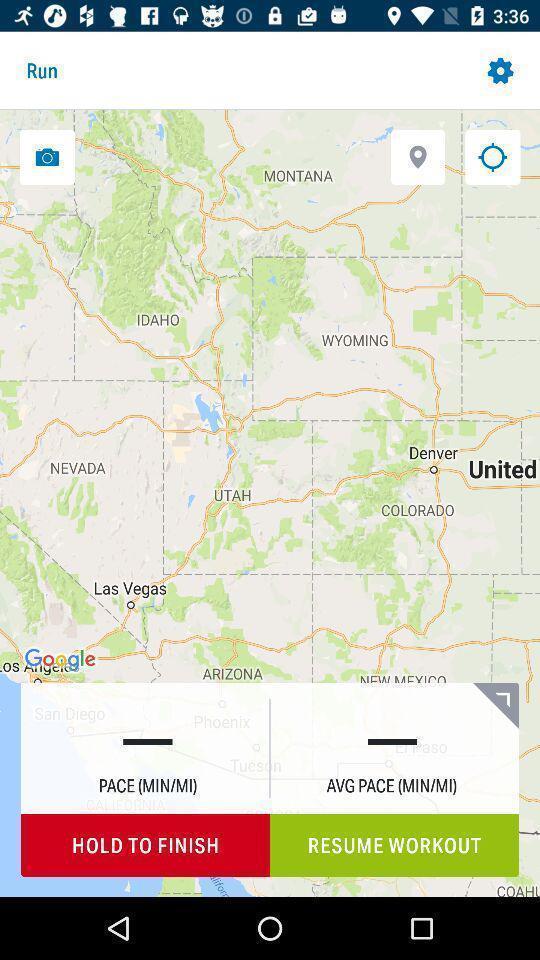Describe the key features of this screenshot. Screen showing map with options. 